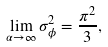Convert formula to latex. <formula><loc_0><loc_0><loc_500><loc_500>\lim _ { \alpha \rightarrow \infty } \sigma _ { \phi } ^ { 2 } = \frac { \pi ^ { 2 } } { 3 } ,</formula> 